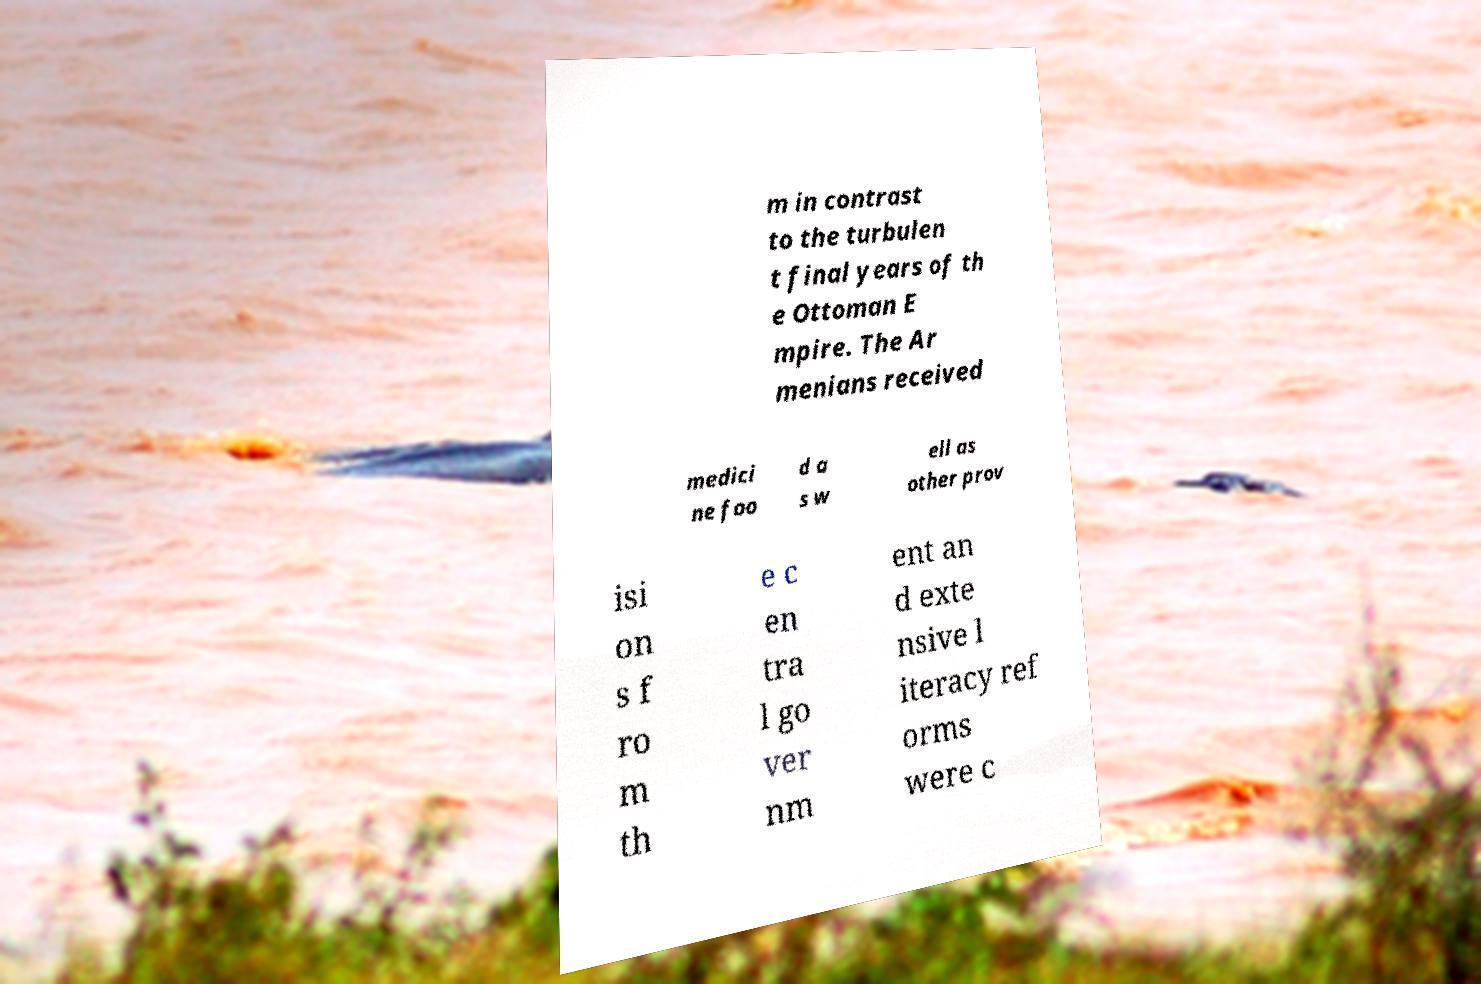I need the written content from this picture converted into text. Can you do that? m in contrast to the turbulen t final years of th e Ottoman E mpire. The Ar menians received medici ne foo d a s w ell as other prov isi on s f ro m th e c en tra l go ver nm ent an d exte nsive l iteracy ref orms were c 